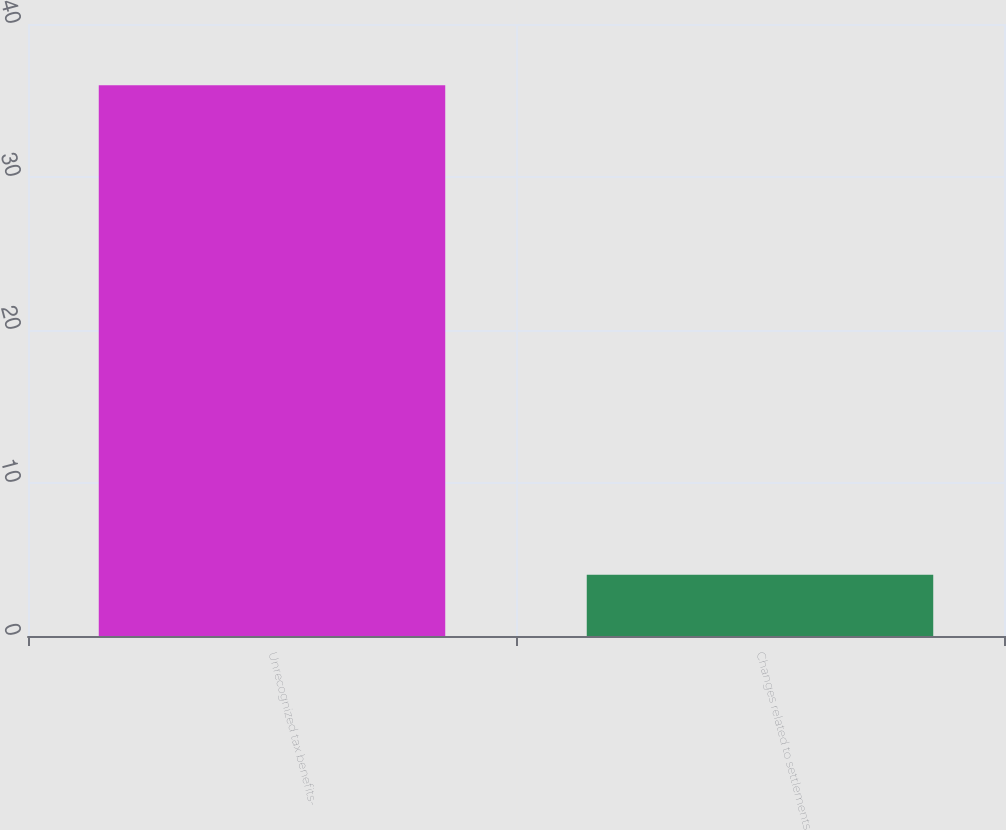<chart> <loc_0><loc_0><loc_500><loc_500><bar_chart><fcel>Unrecognized tax benefits-<fcel>Changes related to settlements<nl><fcel>36<fcel>4<nl></chart> 